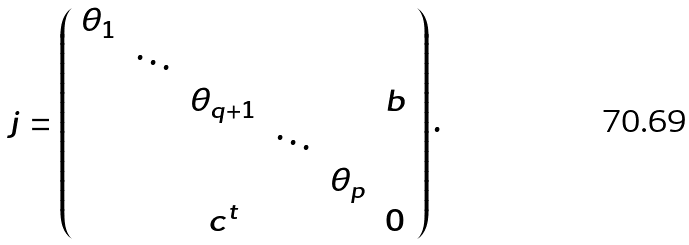Convert formula to latex. <formula><loc_0><loc_0><loc_500><loc_500>j = \left ( \begin{array} { c c c c c c } \theta _ { 1 } & & & & & \\ & \ddots & & & & \\ & & \theta _ { q + 1 } & & & b \\ & & & \ddots & & \\ & & & & \theta _ { p } & \\ & & c ^ { t } & & & 0 \end{array} \right ) .</formula> 